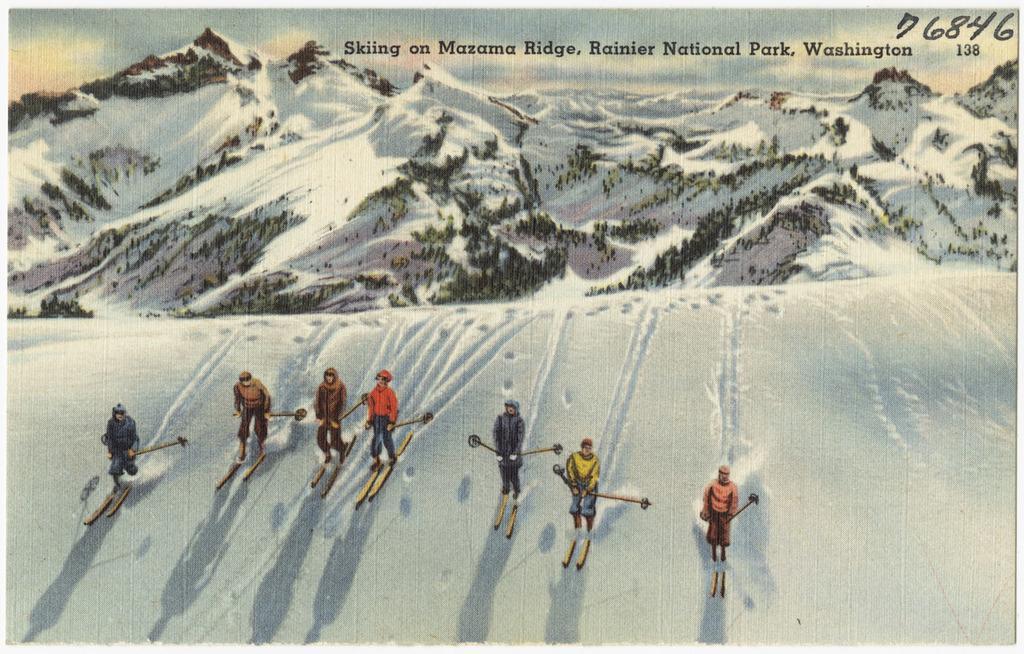Can you describe this image briefly? This is the painting image in which there are persons skiing on snow and there are mountains and there are some texts written on the top of the image. 